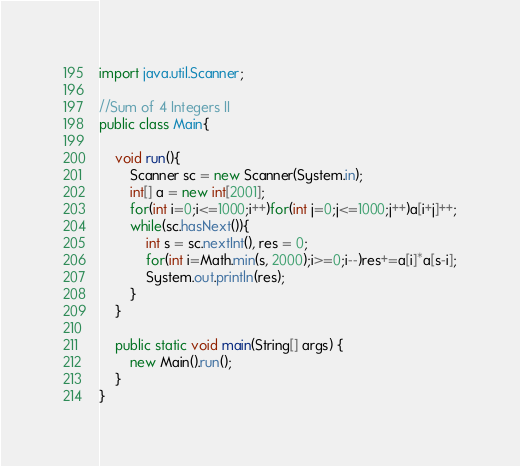<code> <loc_0><loc_0><loc_500><loc_500><_Java_>import java.util.Scanner;

//Sum of 4 Integers II
public class Main{

	void run(){
		Scanner sc = new Scanner(System.in);
		int[] a = new int[2001];
		for(int i=0;i<=1000;i++)for(int j=0;j<=1000;j++)a[i+j]++;
		while(sc.hasNext()){
			int s = sc.nextInt(), res = 0;
			for(int i=Math.min(s, 2000);i>=0;i--)res+=a[i]*a[s-i];
			System.out.println(res);
		}
	}
	
	public static void main(String[] args) {
		new Main().run();
	}
}</code> 